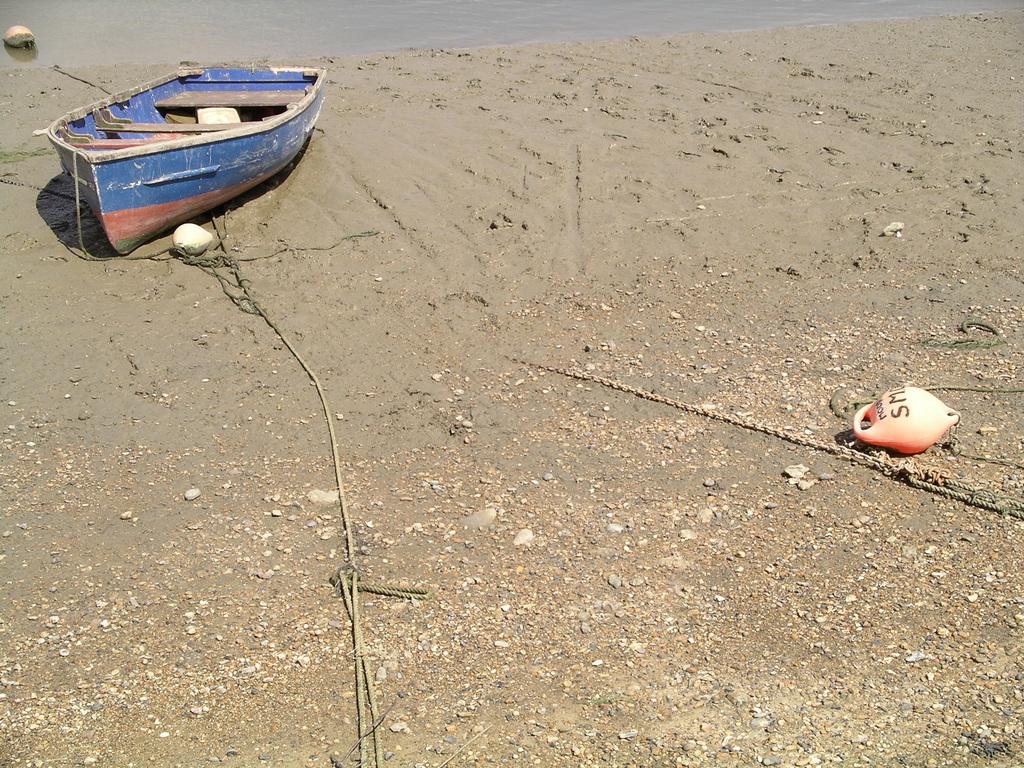What is first letter on the grounded buoy?
Make the answer very short. S. What is second letter on the grounded buoy?
Offer a very short reply. M. 